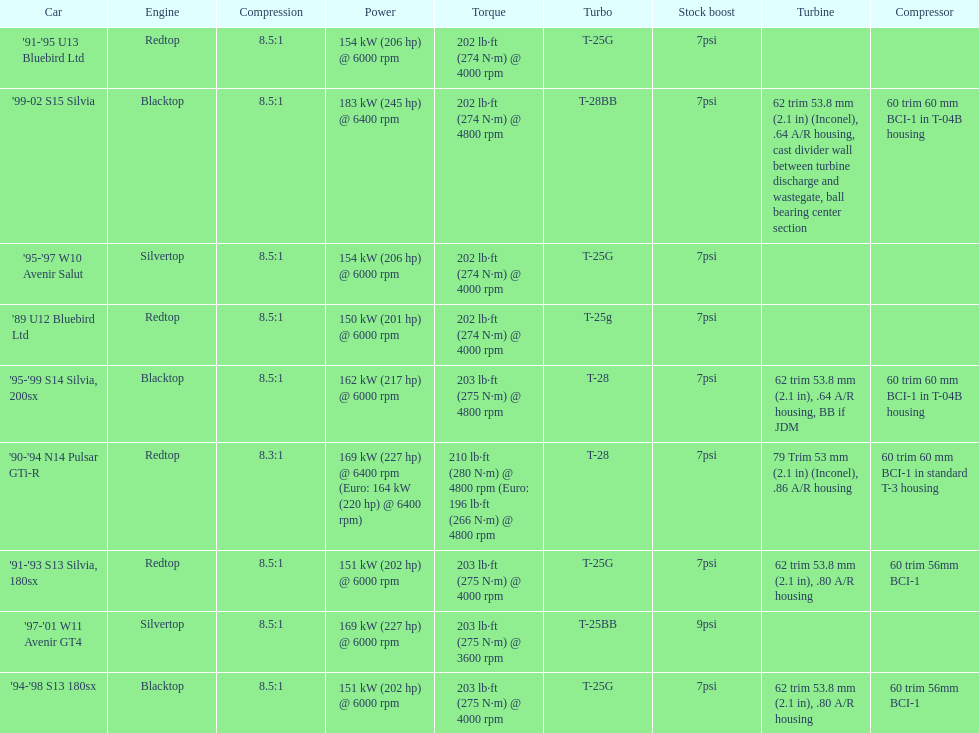Which engine(s) has the least amount of power? Redtop. 